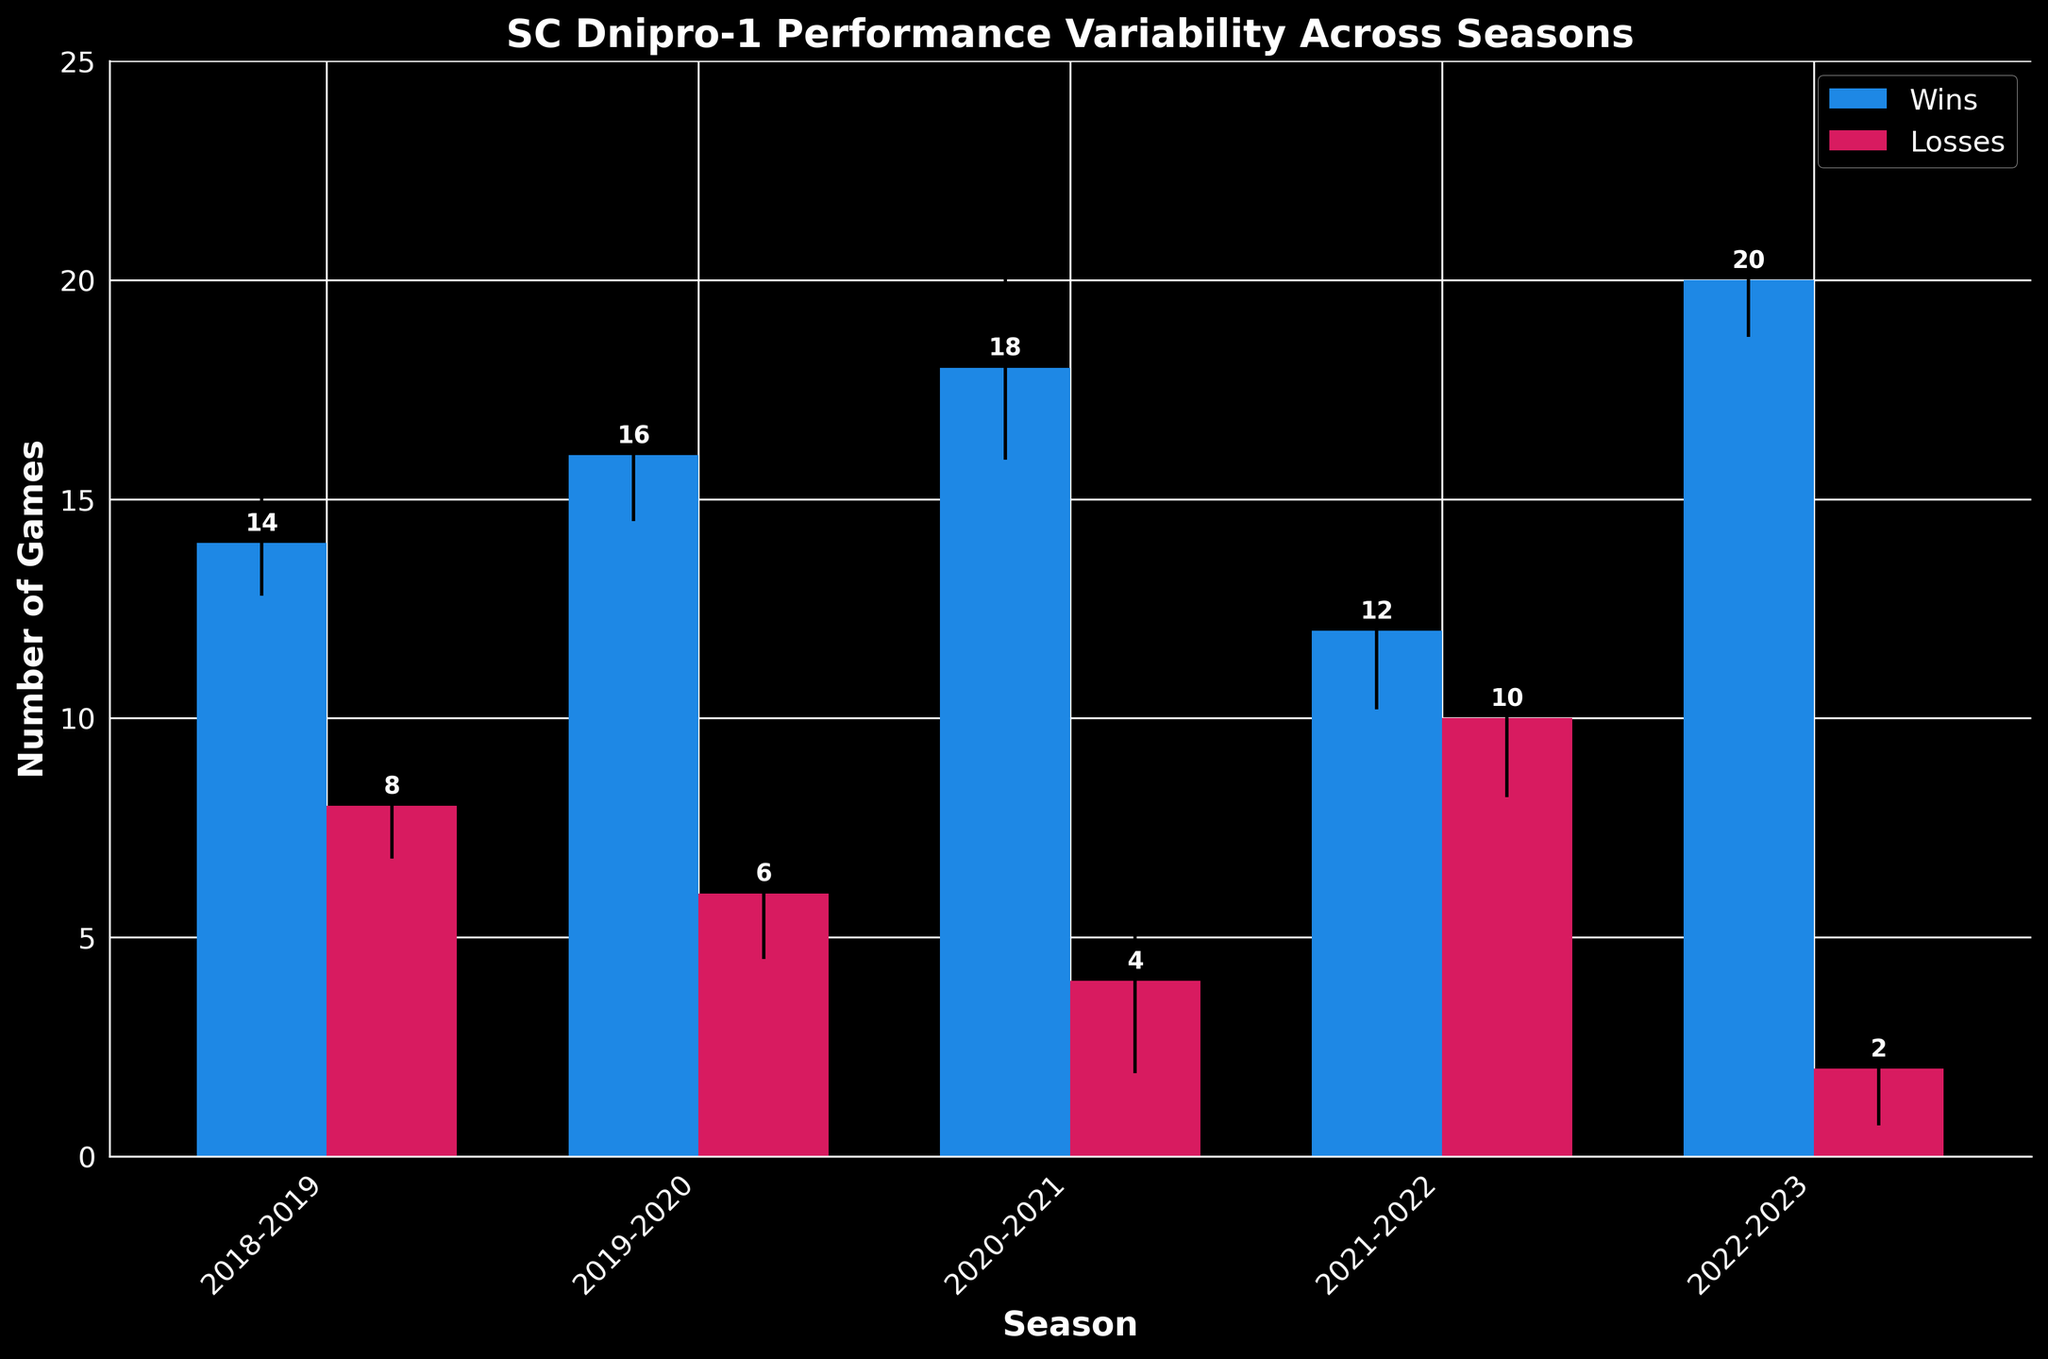How many seasons are displayed in the bar chart? The x-axis of the chart shows different seasons as categories. By counting these, we can determine the number of seasons displayed.
Answer: 5 What is the title of the bar chart? The title is usually displayed at the top of the chart. In this case, it reads "SC Dnipro-1 Performance Variability Across Seasons."
Answer: SC Dnipro-1 Performance Variability Across Seasons What is the average number of wins for the 2019-2020 season? The bar labeled for the 2019-2020 season shows a height corresponding to the number of wins. Based on the data, it is given directly as 16 wins.
Answer: 16 What is the difference in average wins between the 2020-2021 and 2018-2019 seasons? For the 2020-2021 season, the average wins are 18. For the 2018-2019 season, they are 14. Subtracting the latter from the former gives 18 - 14 = 4.
Answer: 4 In which season did SC Dnipro-1 achieve the highest number of average wins? By looking at the heights of the blue bars representing wins, the tallest one indicates the highest number. For the 2022-2023 season, the bar representing wins is the highest.
Answer: 2022-2023 For the 2021-2022 season, is the number of average wins greater or less than the number of average losses? Compare the height of the wins bar (12) to the height of the losses bar (10) within the same season.
Answer: Greater What is the maximum average losses recorded in any season? Observing the heights of the red bars representing losses across all seasons, the highest value is visible in the 2021-2022 season showing 10 losses.
Answer: 10 What is the sum of the average wins for the 2020-2021 and 2022-2023 seasons? The average wins for 2020-2021 are 18, and for 2022-2023, they are 20. Adding these together gives 18 + 20 = 38.
Answer: 38 Which season has the smallest error bars for both wins and losses? Error bars represent the standard deviation in performance. By observing the lengths of the black lines at the top of the bars, the 2022-2023 season has the shortest error bars, indicating the smallest standard deviation.
Answer: 2022-2023 What is the average losses for the 2019-2020 season, and what is the corresponding standard deviation? The bar chart shows the average losses for the 2019-2020 season as 6. The lengths of the error bars represent the standard deviation, which is given directly in the data as 1.5.
Answer: 6 losses, 1.5 standard deviation 